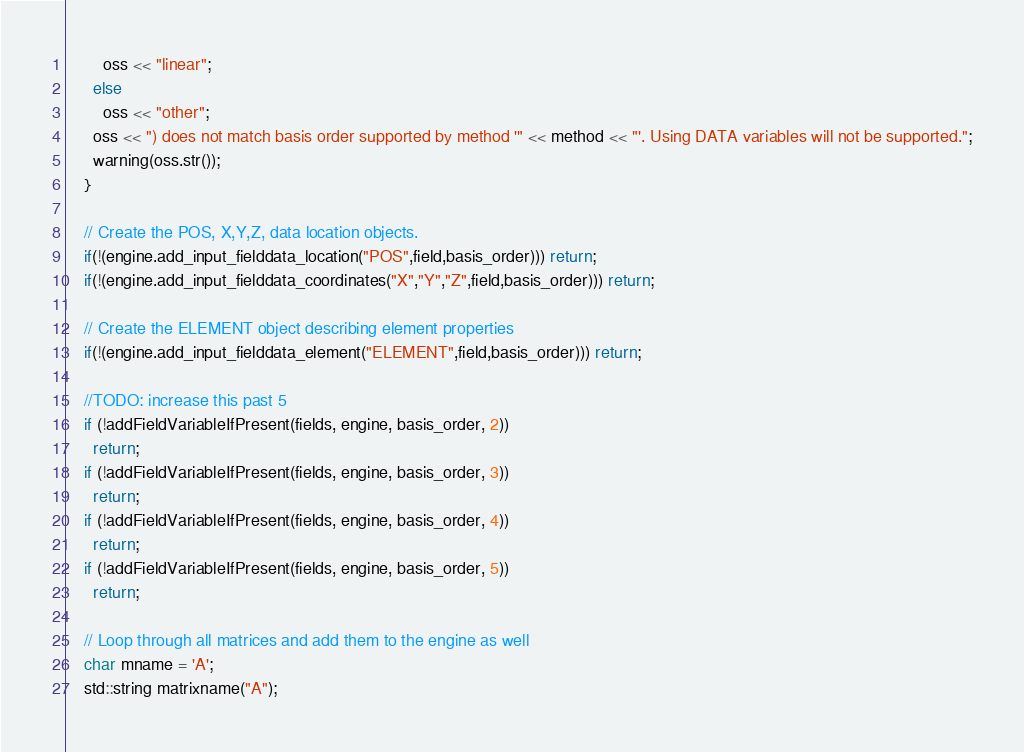Convert code to text. <code><loc_0><loc_0><loc_500><loc_500><_C++_>        oss << "linear";
      else
        oss << "other";
      oss << ") does not match basis order supported by method '" << method << "'. Using DATA variables will not be supported.";
      warning(oss.str());
    }

    // Create the POS, X,Y,Z, data location objects.
    if(!(engine.add_input_fielddata_location("POS",field,basis_order))) return;
    if(!(engine.add_input_fielddata_coordinates("X","Y","Z",field,basis_order))) return;

    // Create the ELEMENT object describing element properties
    if(!(engine.add_input_fielddata_element("ELEMENT",field,basis_order))) return;

    //TODO: increase this past 5
    if (!addFieldVariableIfPresent(fields, engine, basis_order, 2))
      return;
    if (!addFieldVariableIfPresent(fields, engine, basis_order, 3))
      return;
    if (!addFieldVariableIfPresent(fields, engine, basis_order, 4))
      return;
    if (!addFieldVariableIfPresent(fields, engine, basis_order, 5))
      return;

    // Loop through all matrices and add them to the engine as well
    char mname = 'A';
    std::string matrixname("A");
</code> 